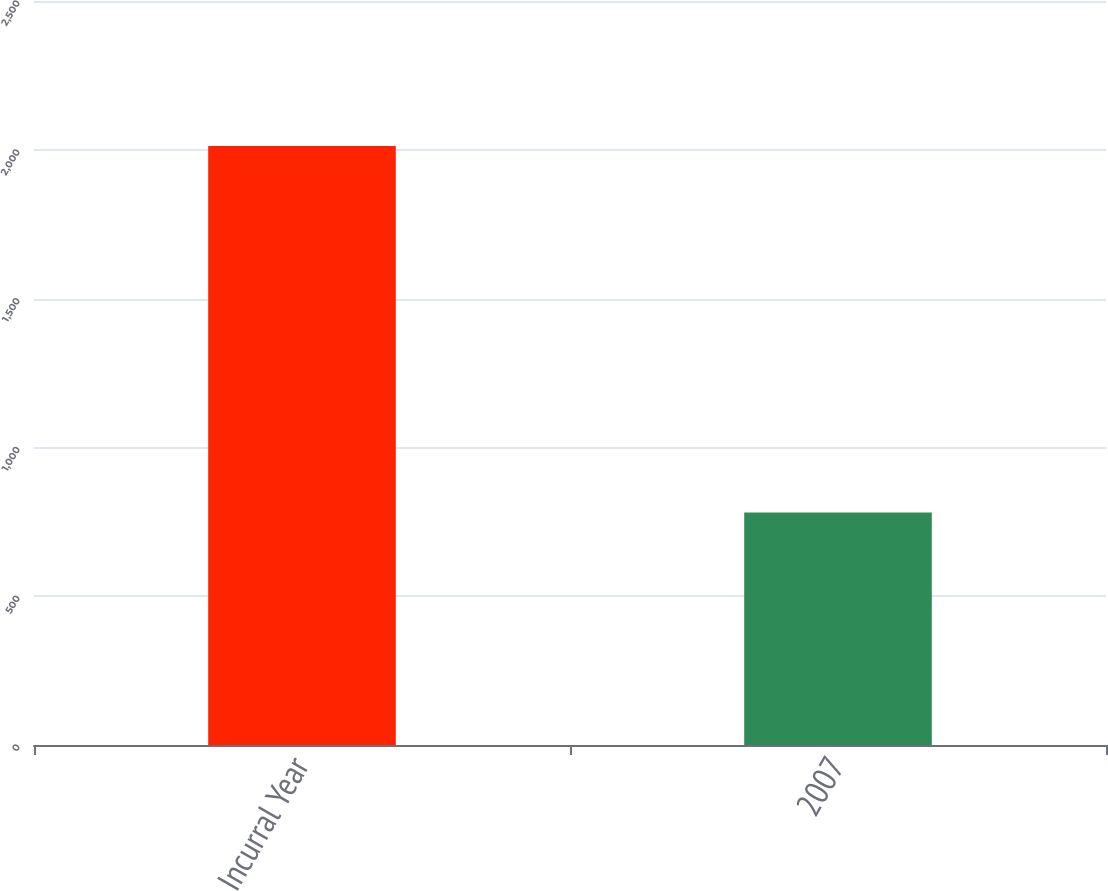Convert chart to OTSL. <chart><loc_0><loc_0><loc_500><loc_500><bar_chart><fcel>Incurral Year<fcel>2007<nl><fcel>2013<fcel>781<nl></chart> 